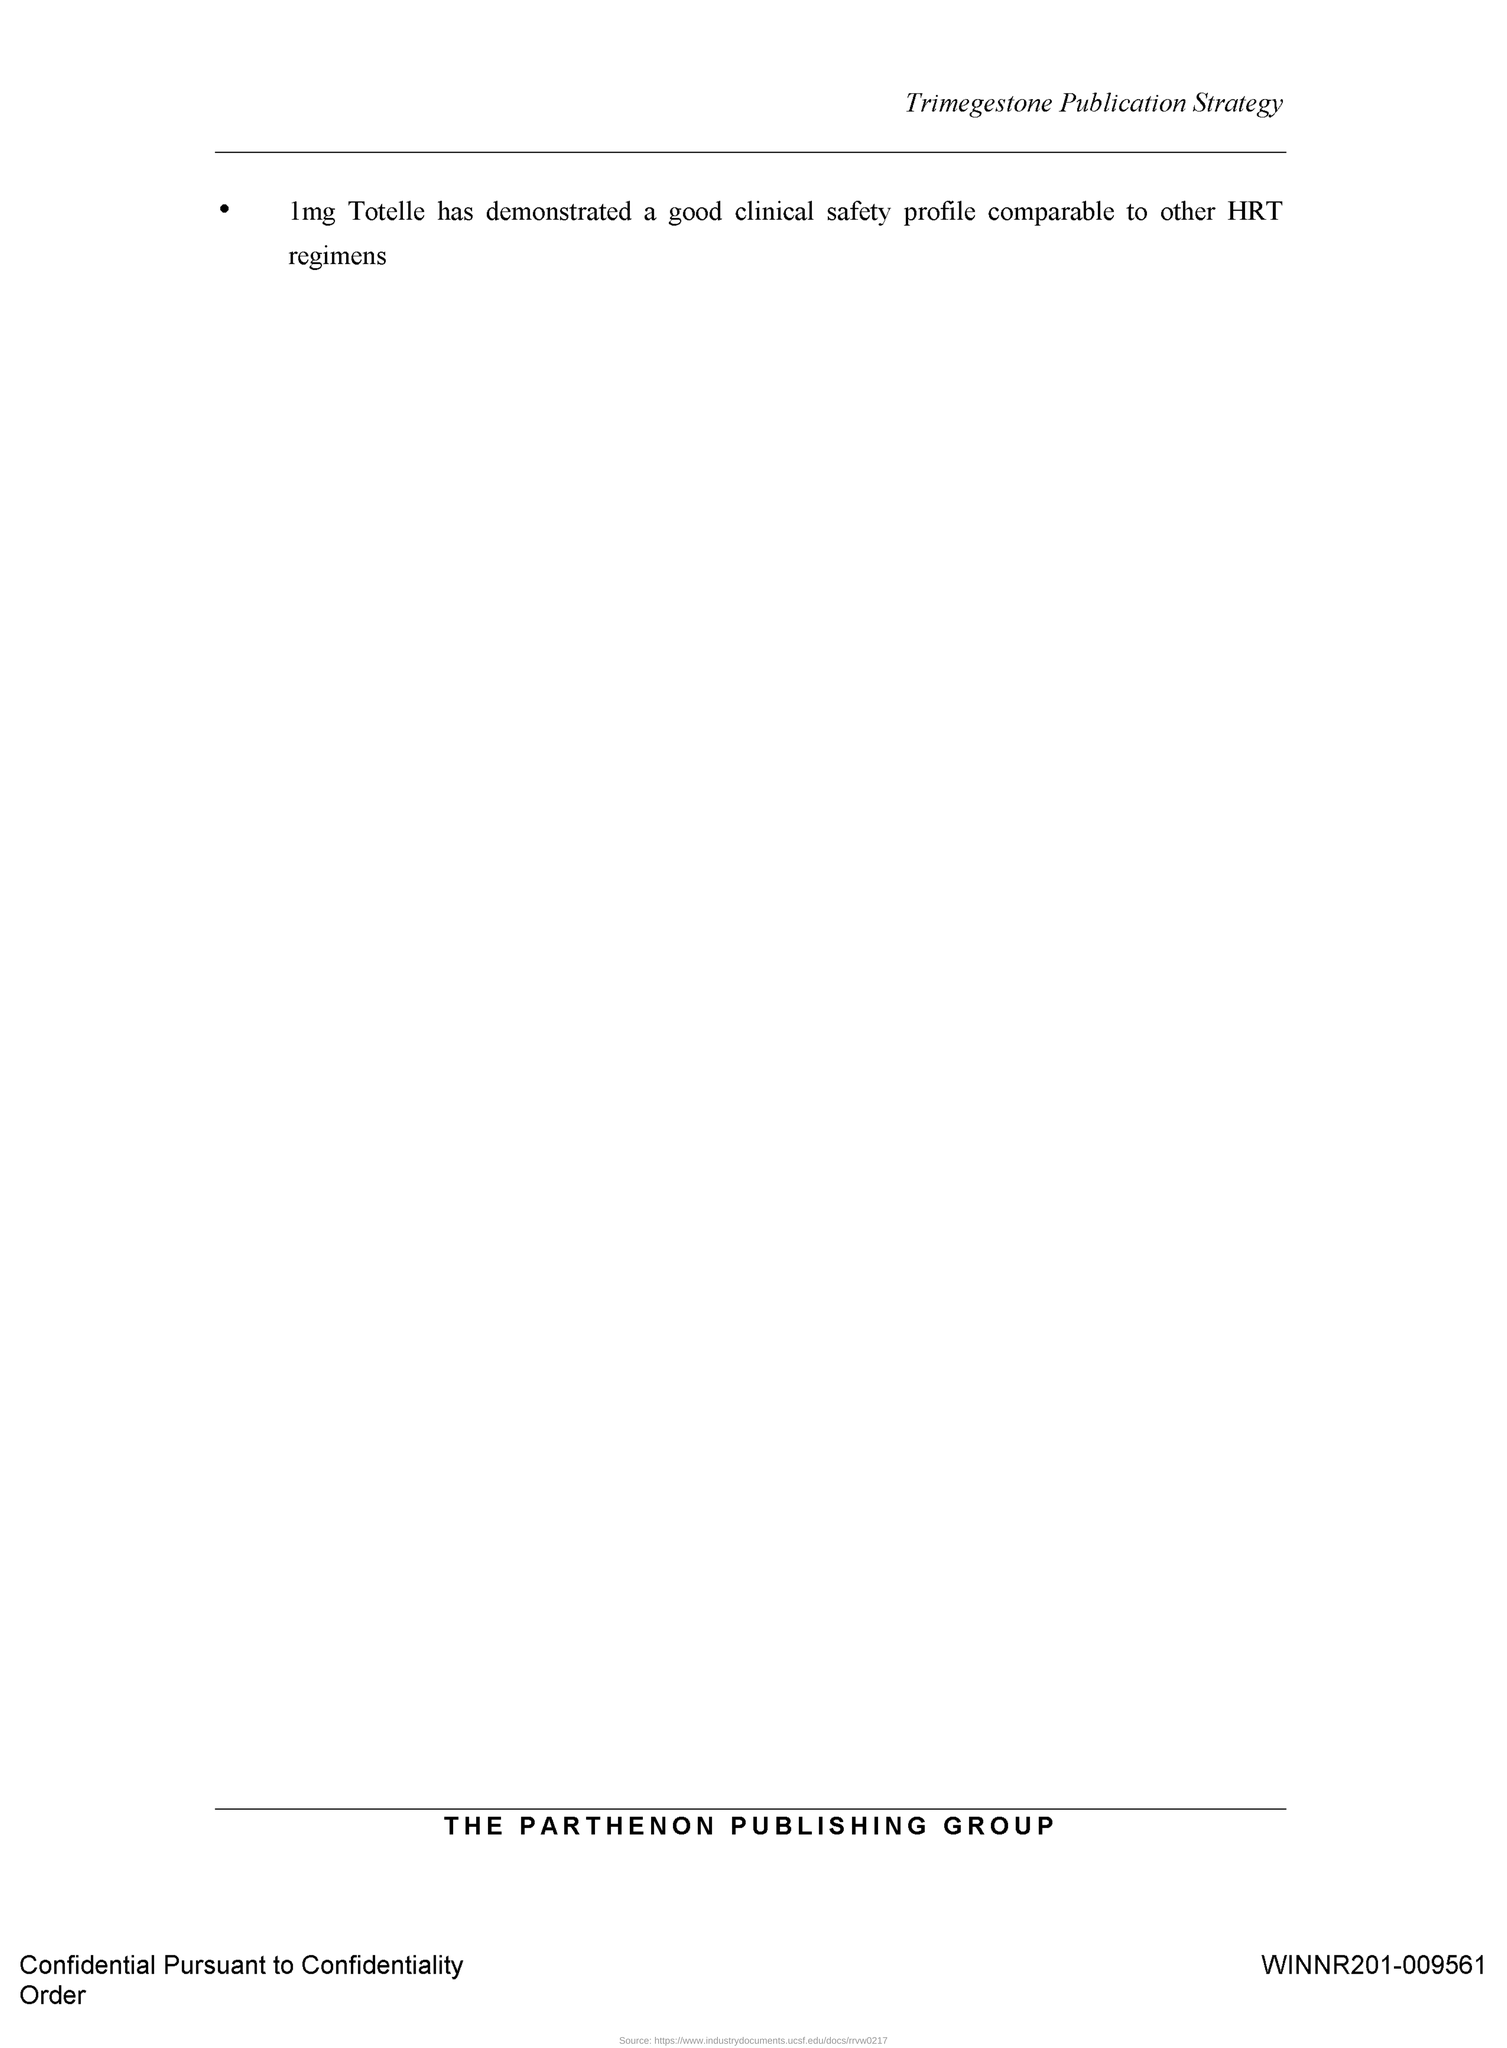Which publishing group is mentioned?
Provide a short and direct response. THE PARTHENON PUBLISHING GROUP. 